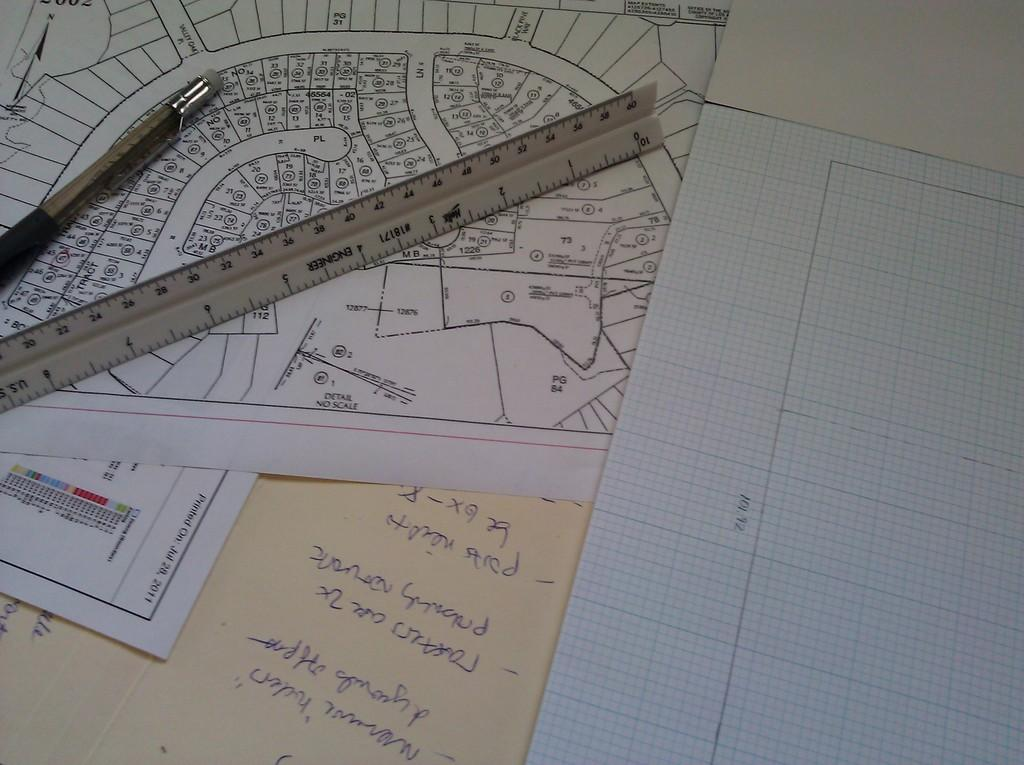<image>
Give a short and clear explanation of the subsequent image. One of the papers was printed in July 2011. 